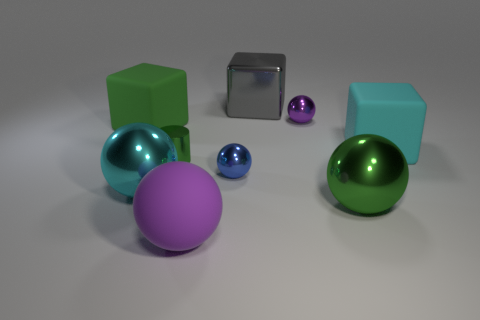What number of blue things are rubber balls or balls?
Provide a short and direct response. 1. There is a cylinder that is the same material as the green sphere; what color is it?
Your answer should be compact. Green. Is there anything else that has the same size as the cyan matte object?
Your answer should be compact. Yes. How many small things are either blue metal balls or balls?
Provide a short and direct response. 2. Are there fewer gray metallic cubes than tiny purple metal cylinders?
Your answer should be very brief. No. The other small metal object that is the same shape as the tiny blue object is what color?
Offer a very short reply. Purple. Is there any other thing that has the same shape as the small green metal thing?
Offer a terse response. No. Is the number of blue metal things greater than the number of big metal objects?
Ensure brevity in your answer.  No. How many other objects are there of the same material as the green cylinder?
Make the answer very short. 5. The big object in front of the green thing on the right side of the small purple metal thing behind the large green rubber thing is what shape?
Provide a short and direct response. Sphere. 